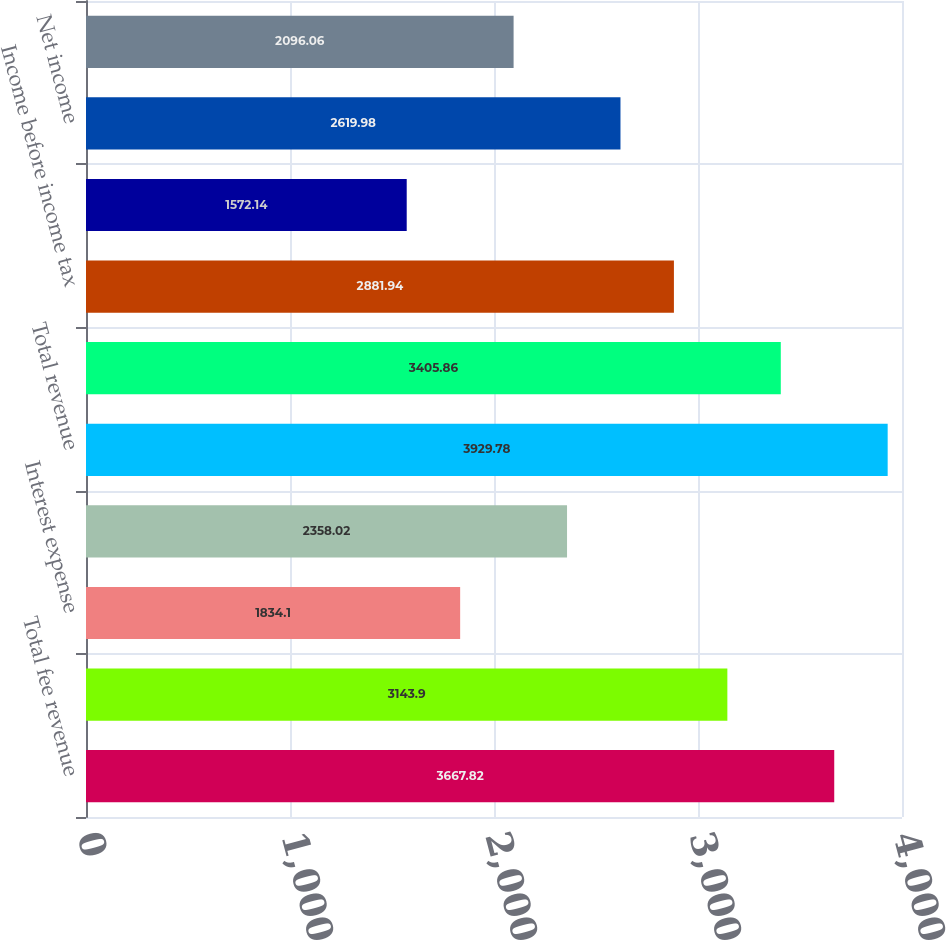<chart> <loc_0><loc_0><loc_500><loc_500><bar_chart><fcel>Total fee revenue<fcel>Interest income<fcel>Interest expense<fcel>Net interest income<fcel>Total revenue<fcel>Total expenses<fcel>Income before income tax<fcel>Income tax expense (benefit)<fcel>Net income<fcel>Net income available to common<nl><fcel>3667.82<fcel>3143.9<fcel>1834.1<fcel>2358.02<fcel>3929.78<fcel>3405.86<fcel>2881.94<fcel>1572.14<fcel>2619.98<fcel>2096.06<nl></chart> 